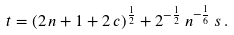Convert formula to latex. <formula><loc_0><loc_0><loc_500><loc_500>t = ( 2 \, n + 1 + 2 \, c ) ^ { \frac { 1 } { 2 } } + 2 ^ { - \frac { 1 } { 2 } } \, n ^ { - \frac { 1 } { 6 } } \, s \, .</formula> 